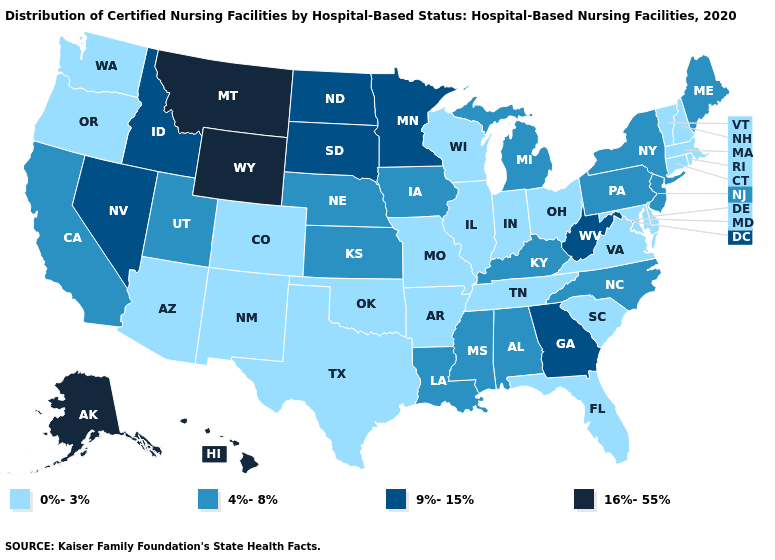Name the states that have a value in the range 4%-8%?
Quick response, please. Alabama, California, Iowa, Kansas, Kentucky, Louisiana, Maine, Michigan, Mississippi, Nebraska, New Jersey, New York, North Carolina, Pennsylvania, Utah. Name the states that have a value in the range 0%-3%?
Be succinct. Arizona, Arkansas, Colorado, Connecticut, Delaware, Florida, Illinois, Indiana, Maryland, Massachusetts, Missouri, New Hampshire, New Mexico, Ohio, Oklahoma, Oregon, Rhode Island, South Carolina, Tennessee, Texas, Vermont, Virginia, Washington, Wisconsin. Does Delaware have a lower value than Wyoming?
Answer briefly. Yes. Does California have the lowest value in the West?
Write a very short answer. No. Name the states that have a value in the range 9%-15%?
Keep it brief. Georgia, Idaho, Minnesota, Nevada, North Dakota, South Dakota, West Virginia. Is the legend a continuous bar?
Answer briefly. No. What is the highest value in the USA?
Be succinct. 16%-55%. What is the value of Texas?
Short answer required. 0%-3%. What is the value of Maine?
Concise answer only. 4%-8%. Does Hawaii have a lower value than Connecticut?
Keep it brief. No. Does Indiana have a lower value than Ohio?
Concise answer only. No. Name the states that have a value in the range 16%-55%?
Write a very short answer. Alaska, Hawaii, Montana, Wyoming. Does Maryland have the lowest value in the USA?
Give a very brief answer. Yes. What is the highest value in states that border Missouri?
Concise answer only. 4%-8%. What is the value of Arizona?
Be succinct. 0%-3%. 